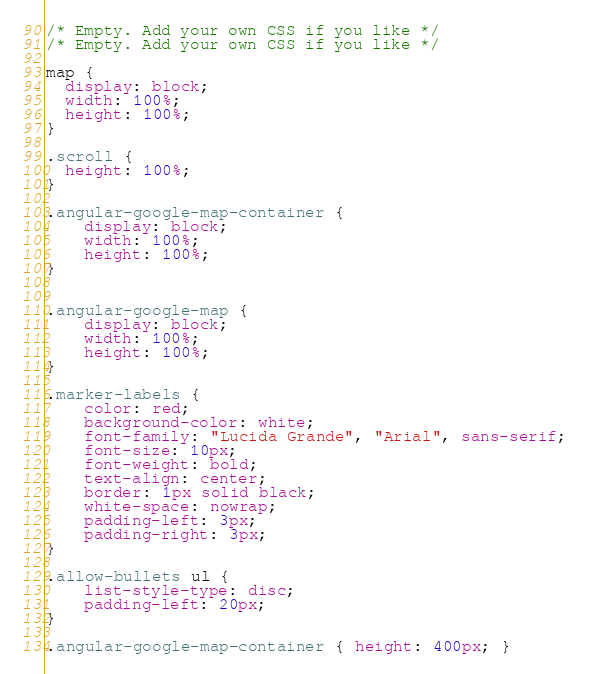<code> <loc_0><loc_0><loc_500><loc_500><_CSS_>/* Empty. Add your own CSS if you like */
/* Empty. Add your own CSS if you like */

map {
  display: block;
  width: 100%;
  height: 100%;
}

.scroll {
  height: 100%;
}

.angular-google-map-container {
    display: block;
    width: 100%;
    height: 100%;
}


.angular-google-map {
    display: block;
    width: 100%;
    height: 100%;
}

.marker-labels {
    color: red;
    background-color: white;
    font-family: "Lucida Grande", "Arial", sans-serif;
    font-size: 10px;
    font-weight: bold;
    text-align: center;
    border: 1px solid black;
    white-space: nowrap;
    padding-left: 3px;
    padding-right: 3px;
}

.allow-bullets ul {
    list-style-type: disc;
    padding-left: 20px;
}

.angular-google-map-container { height: 400px; }</code> 